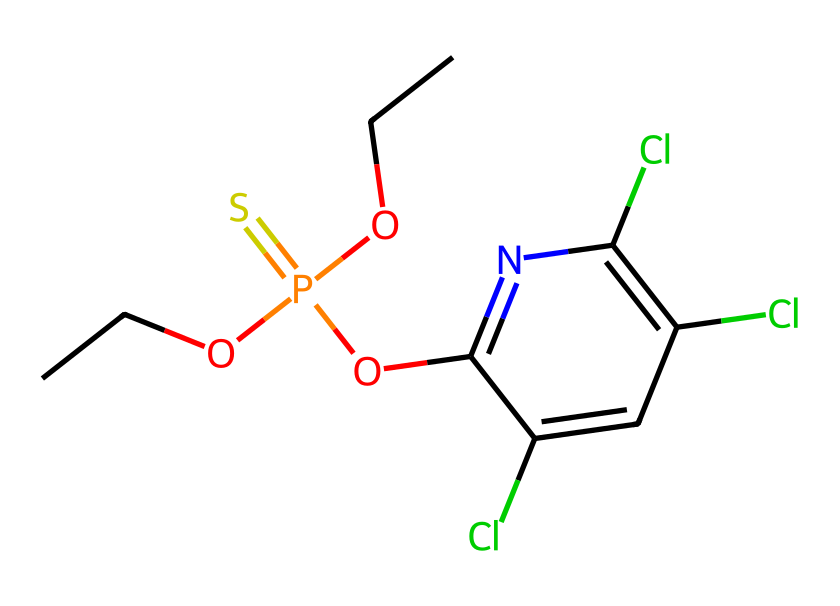How many chlorine atoms are present in this chemical? By examining the SMILES representation, the 'Cl' symbols indicate chlorine atoms attached to the benzene ring of the chemical structure. Counting these symbols shows there are three chlorine atoms.
Answer: 3 What is the functional group present in this pesticide? The SMILES representation includes 'P(=S)' which indicates a phosphorothioate functional group, characteristic of organophosphates commonly used in pesticides.
Answer: phosphorothioate How many oxygen atoms are present in this chemical? In the SMILES string, the presence of 'O' indicates oxygen atoms. Counting instances of 'O' shows there are four oxygen atoms in total.
Answer: 4 What type of pesticide is represented by this chemical structure? This chemical belongs to the class of organophosphate pesticides, as evidenced by the presence of phosphorus and sulfur in the structure indicated by 'P(=S)'.
Answer: organophosphate Does this chemical contain a nitrogen atom? The 'n' symbol in the SMILES indicates a nitrogen atom, confirming its presence in the chemical structure.
Answer: yes What can be inferred about the toxicity of this pesticide? Organophosphate pesticides are known for their neurotoxic effects due to their ability to inhibit acetylcholinesterase. This characteristic is inferred from the chemical structure containing phosphorus, which is typical of such toxins.
Answer: neurotoxic How many carbon atoms are in this chemical? By reviewing the SMILES representation, each 'C' represents a carbon atom. Counting all carbon atoms leads to a total of seven carbon atoms present in the structure.
Answer: 7 